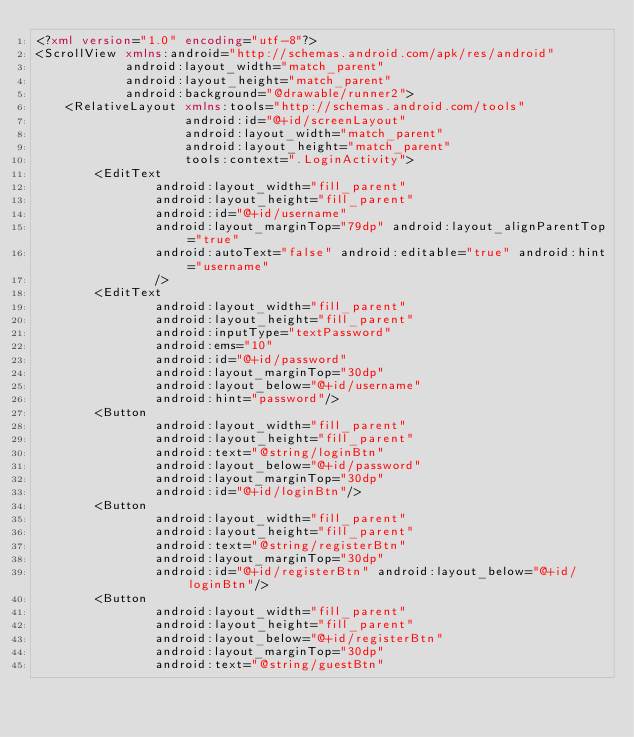<code> <loc_0><loc_0><loc_500><loc_500><_XML_><?xml version="1.0" encoding="utf-8"?>
<ScrollView xmlns:android="http://schemas.android.com/apk/res/android"
            android:layout_width="match_parent"
            android:layout_height="match_parent"
            android:background="@drawable/runner2">
    <RelativeLayout xmlns:tools="http://schemas.android.com/tools"
                    android:id="@+id/screenLayout"
                    android:layout_width="match_parent"
                    android:layout_height="match_parent"
                    tools:context=".LoginActivity">
        <EditText
                android:layout_width="fill_parent"
                android:layout_height="fill_parent"
                android:id="@+id/username"
                android:layout_marginTop="79dp" android:layout_alignParentTop="true"
                android:autoText="false" android:editable="true" android:hint="username"
                />
        <EditText
                android:layout_width="fill_parent"
                android:layout_height="fill_parent"
                android:inputType="textPassword"
                android:ems="10"
                android:id="@+id/password"
                android:layout_marginTop="30dp"
                android:layout_below="@+id/username"
                android:hint="password"/>
        <Button
                android:layout_width="fill_parent"
                android:layout_height="fill_parent"
                android:text="@string/loginBtn"
                android:layout_below="@+id/password"
                android:layout_marginTop="30dp"
                android:id="@+id/loginBtn"/>
        <Button
                android:layout_width="fill_parent"
                android:layout_height="fill_parent"
                android:text="@string/registerBtn"
                android:layout_marginTop="30dp"
                android:id="@+id/registerBtn" android:layout_below="@+id/loginBtn"/>
        <Button
                android:layout_width="fill_parent"
                android:layout_height="fill_parent"
                android:layout_below="@+id/registerBtn"
                android:layout_marginTop="30dp"
                android:text="@string/guestBtn"</code> 